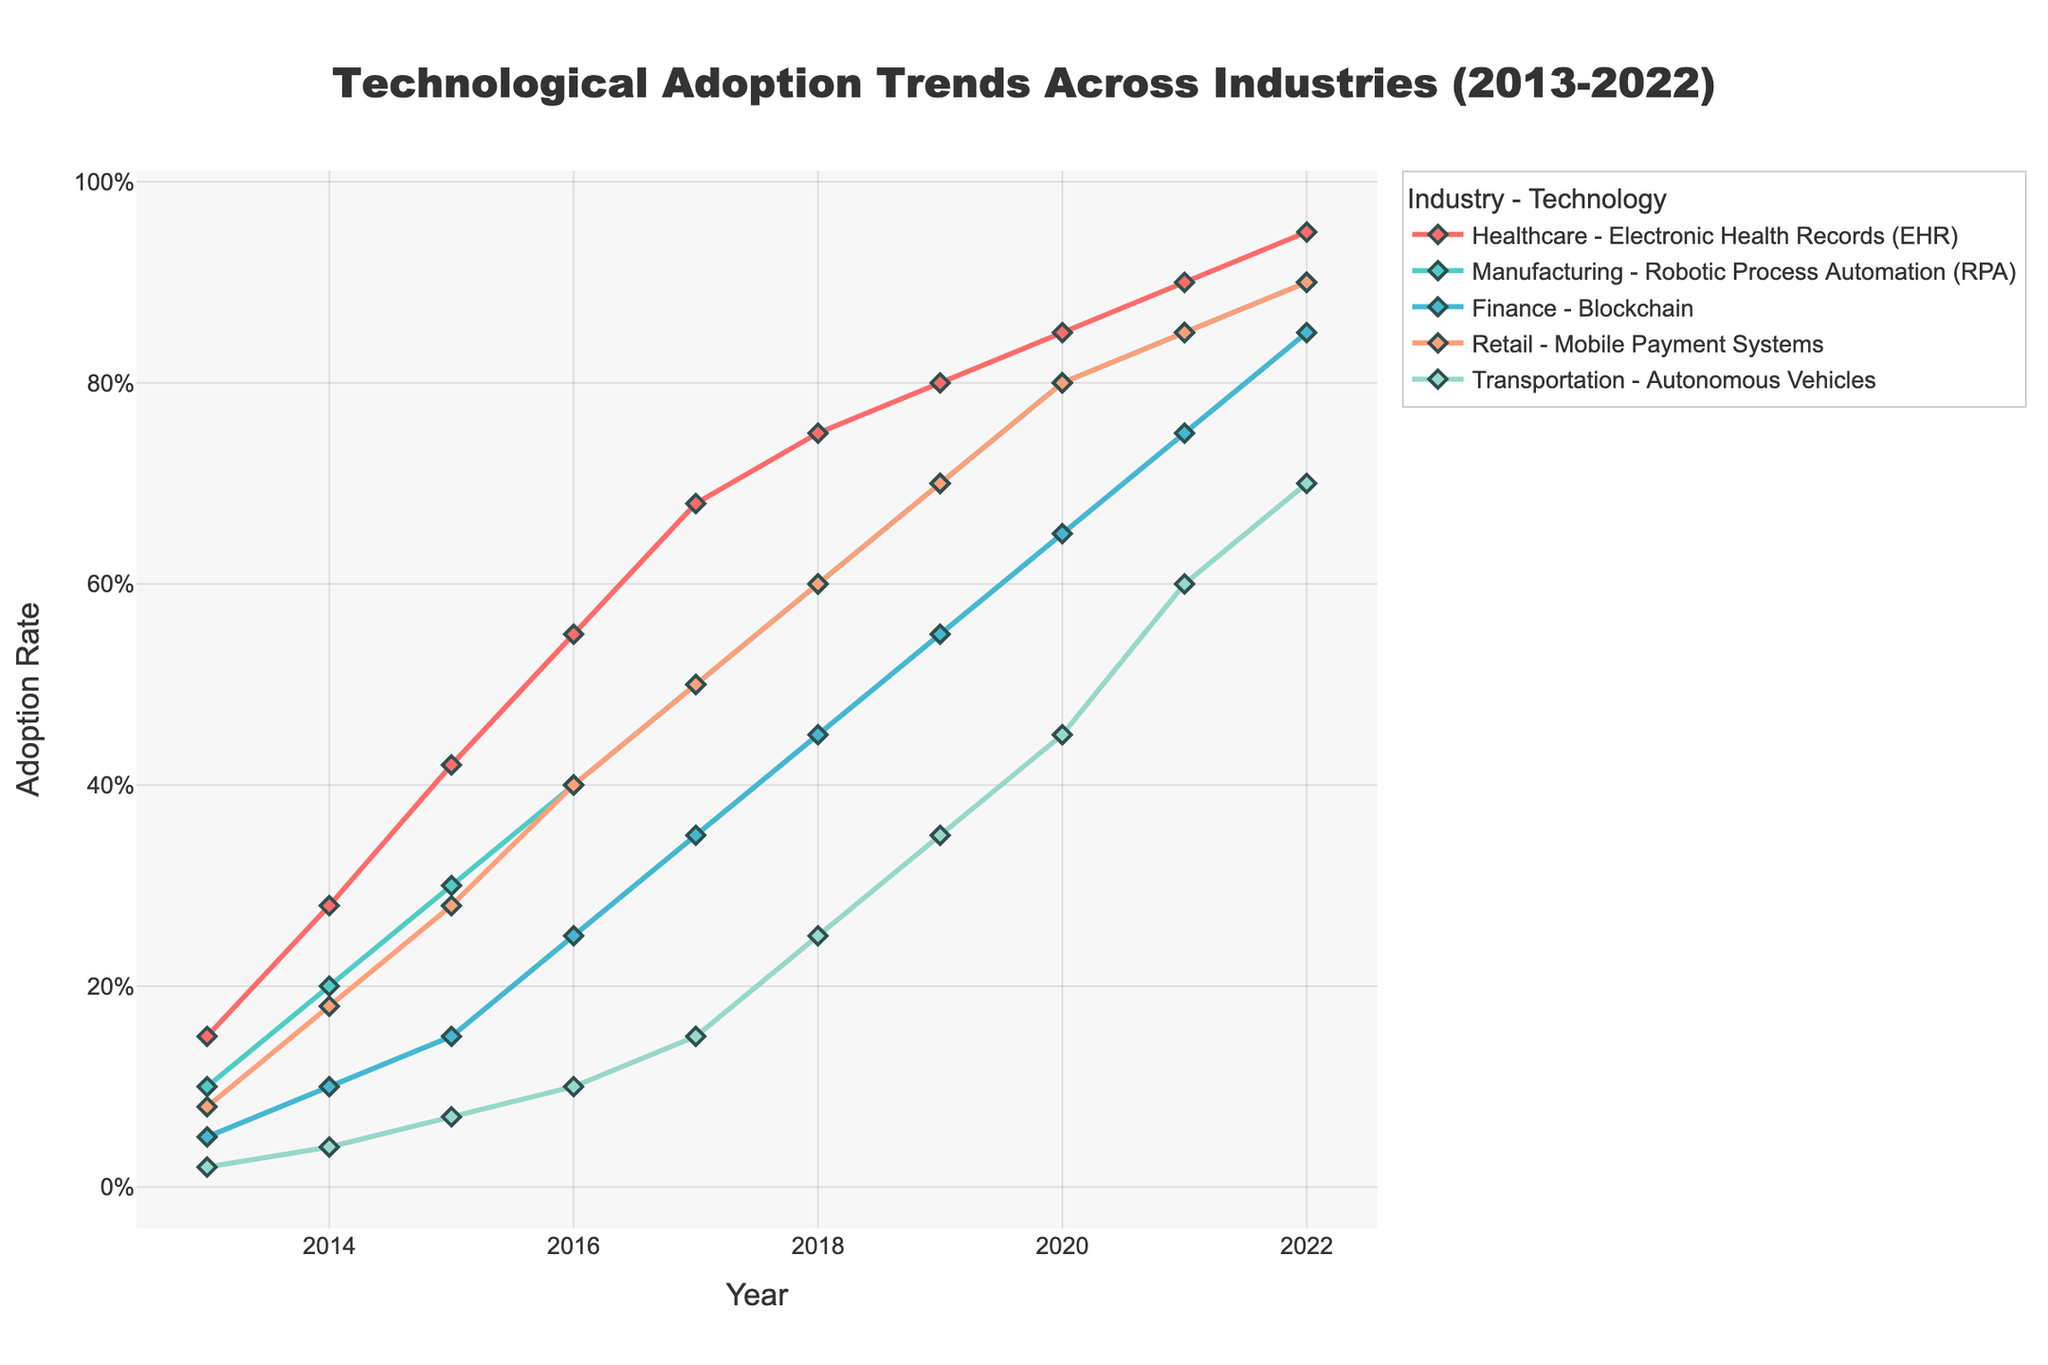What is the title of the plot? The title is usually displayed at the top of the plot. In this case, it indicates the scope and focus of the visualized data.
Answer: Technological Adoption Trends Across Industries (2013-2022) What is the adoption rate of Electronic Health Records (EHR) in Healthcare in the year 2016? Locate the year 2016 on the x-axis, and find the corresponding data point for Healthcare (usually with a specific line color and marker). Read the y-axis value at this point.
Answer: 55% Which technology in the Finance industry had an 85% adoption rate in 2022? Identify the lines and markers specific to the Finance industry in 2022 and note the technology name associated with the 85% data point.
Answer: Blockchain Compare the adoption rates of Mobile Payment Systems in the Retail industry in the years 2013 and 2017. What is the difference? Locate the data points for Retail for the years 2013 and 2017, note the adoption rates, then calculate the difference: 50% - 8%.
Answer: 42% Which industry had the steepest increase in adoption rate from 2016 to 2021, and what technology was it for? Compare the slopes of the lines for each industry between the years 2016 and 2021 to find the steepest one. The steepest slope corresponds to the highest increase.
Answer: Transportation, Autonomous Vehicles How did the adoption rate of Blockchain in Finance compare to Robotic Process Automation (RPA) in Manufacturing in 2019? Find the data points for both Blockchain and RPA in 2019. Compare their values on the y-axis.
Answer: Blockchain (55%) was lower than RPA (70%) What trend can you notice in the Healthcare industry's adoption of Electronic Health Records over the last decade? Observe the line for Healthcare across the years 2013 to 2022 to determine the overall direction and characteristics of the trend.
Answer: Consistently increasing Which year did the Retail industry see a 60% adoption rate for Mobile Payment Systems? Locate the data point for Retail that corresponds to a 60% adoption rate and find the associated year on the x-axis.
Answer: 2018 Between which two consecutive years did the Finance industry see the largest annual increase in Blockchain adoption rate? Identify the yearly increments in the data points for Blockchain in Finance, and find the largest increment between two consecutive years.
Answer: 2019 to 2020 In which year did Healthcare, Manufacturing, and Retail all have an adoption rate of at least 80% for their respective technologies? Locate the data points for Healthcare, Manufacturing, and Retail that are at least 80% on the y-axis, and find the corresponding year/s on the x-axis.
Answer: 2020 